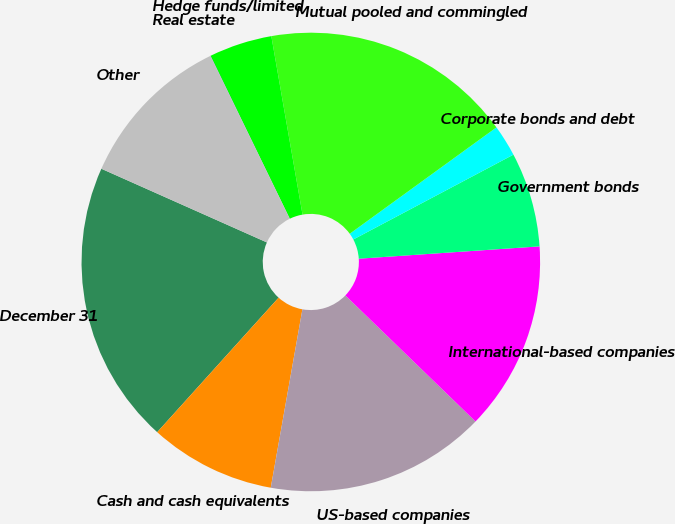Convert chart. <chart><loc_0><loc_0><loc_500><loc_500><pie_chart><fcel>December 31<fcel>Cash and cash equivalents<fcel>US-based companies<fcel>International-based companies<fcel>Government bonds<fcel>Corporate bonds and debt<fcel>Mutual pooled and commingled<fcel>Hedge funds/limited<fcel>Real estate<fcel>Other<nl><fcel>19.98%<fcel>8.89%<fcel>15.55%<fcel>13.33%<fcel>6.67%<fcel>2.23%<fcel>17.77%<fcel>4.45%<fcel>0.02%<fcel>11.11%<nl></chart> 